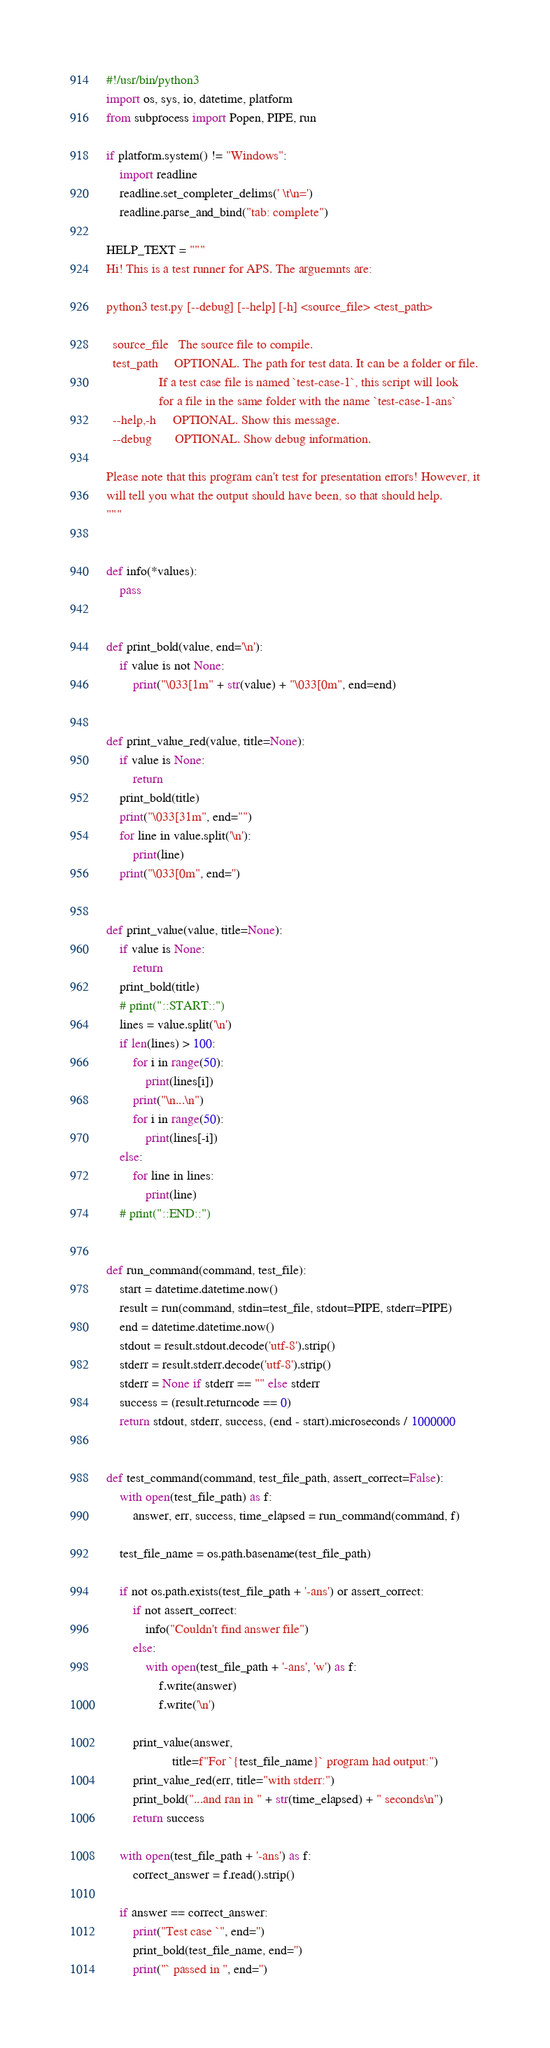Convert code to text. <code><loc_0><loc_0><loc_500><loc_500><_Python_>#!/usr/bin/python3
import os, sys, io, datetime, platform
from subprocess import Popen, PIPE, run

if platform.system() != "Windows":
    import readline
    readline.set_completer_delims(' \t\n=')
    readline.parse_and_bind("tab: complete")

HELP_TEXT = """
Hi! This is a test runner for APS. The arguemnts are:

python3 test.py [--debug] [--help] [-h] <source_file> <test_path>

  source_file   The source file to compile.
  test_path     OPTIONAL. The path for test data. It can be a folder or file.
                If a test case file is named `test-case-1`, this script will look
                for a file in the same folder with the name `test-case-1-ans`
  --help,-h     OPTIONAL. Show this message.
  --debug       OPTIONAL. Show debug information.

Please note that this program can't test for presentation errors! However, it
will tell you what the output should have been, so that should help.
"""


def info(*values):
    pass


def print_bold(value, end='\n'):
    if value is not None:
        print("\033[1m" + str(value) + "\033[0m", end=end)


def print_value_red(value, title=None):
    if value is None:
        return
    print_bold(title)
    print("\033[31m", end="")
    for line in value.split('\n'):
        print(line)
    print("\033[0m", end='')


def print_value(value, title=None):
    if value is None:
        return
    print_bold(title)
    # print("::START::")
    lines = value.split('\n')
    if len(lines) > 100:
        for i in range(50):
            print(lines[i])
        print("\n...\n")
        for i in range(50):
            print(lines[-i])
    else:
        for line in lines:
            print(line)
    # print("::END::")


def run_command(command, test_file):
    start = datetime.datetime.now()
    result = run(command, stdin=test_file, stdout=PIPE, stderr=PIPE)
    end = datetime.datetime.now()
    stdout = result.stdout.decode('utf-8').strip()
    stderr = result.stderr.decode('utf-8').strip()
    stderr = None if stderr == "" else stderr
    success = (result.returncode == 0)
    return stdout, stderr, success, (end - start).microseconds / 1000000


def test_command(command, test_file_path, assert_correct=False):
    with open(test_file_path) as f:
        answer, err, success, time_elapsed = run_command(command, f)

    test_file_name = os.path.basename(test_file_path)

    if not os.path.exists(test_file_path + '-ans') or assert_correct:
        if not assert_correct:
            info("Couldn't find answer file")
        else:
            with open(test_file_path + '-ans', 'w') as f:
                f.write(answer)
                f.write('\n')

        print_value(answer,
                    title=f"For `{test_file_name}` program had output:")
        print_value_red(err, title="with stderr:")
        print_bold("...and ran in " + str(time_elapsed) + " seconds\n")
        return success

    with open(test_file_path + '-ans') as f:
        correct_answer = f.read().strip()

    if answer == correct_answer:
        print("Test case `", end='')
        print_bold(test_file_name, end='')
        print("` passed in ", end='')</code> 